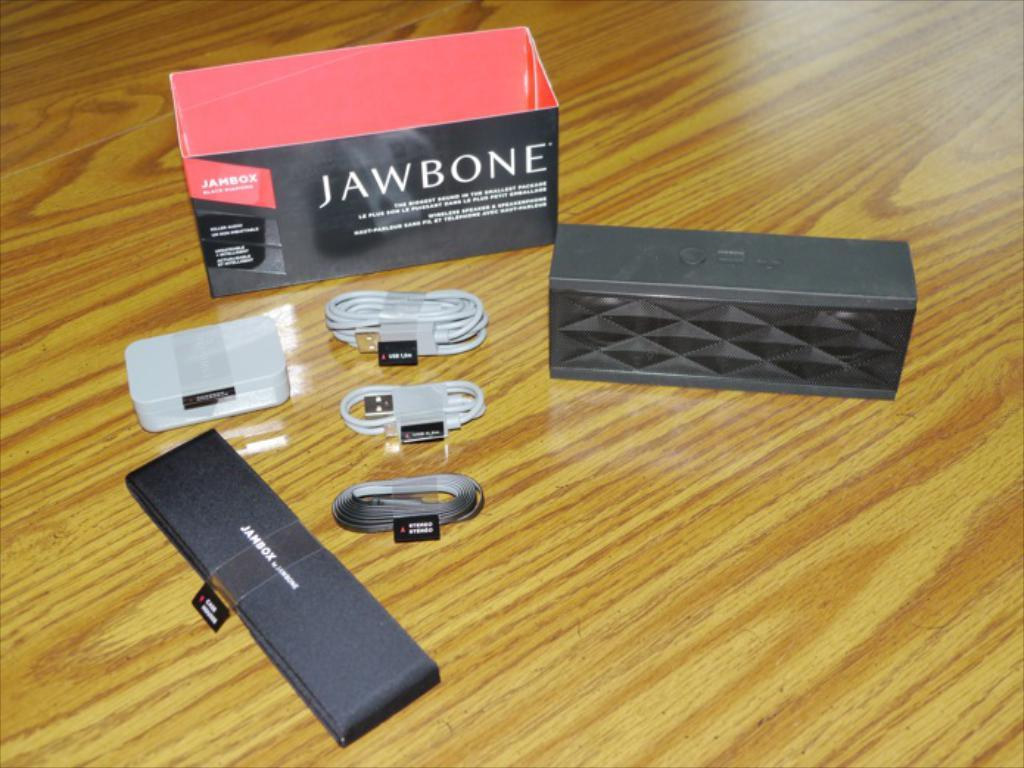<image>
Write a terse but informative summary of the picture. A box that says "jawbone" sits with some cables and other smaller boxes. 